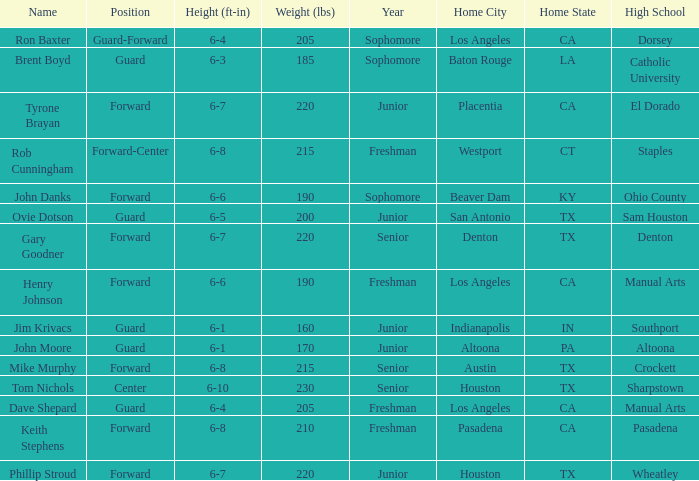What is the Position with a Year with freshman, and a Weight larger than 210? Forward-Center. 